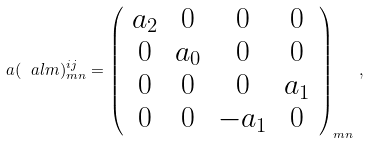Convert formula to latex. <formula><loc_0><loc_0><loc_500><loc_500>a ( \ a l m ) ^ { i j } _ { m n } = \left ( \begin{array} { c c c c } a _ { 2 } & 0 & 0 & 0 \\ 0 & a _ { 0 } & 0 & 0 \\ 0 & 0 & 0 & a _ { 1 } \\ 0 & 0 & - a _ { 1 } & 0 \end{array} \right ) _ { m n } \, ,</formula> 